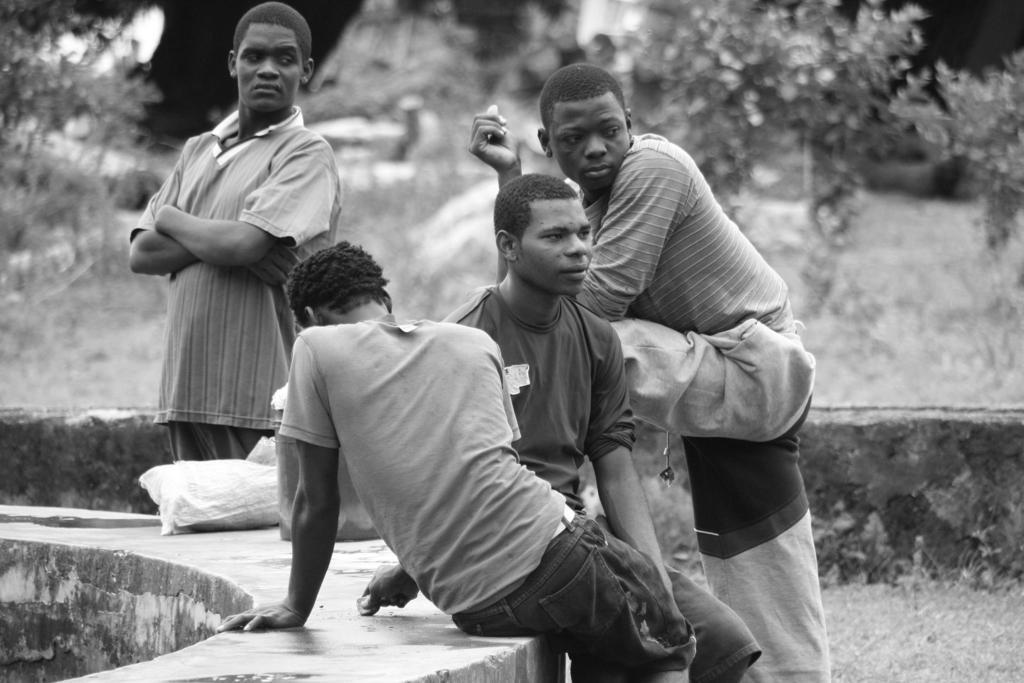How many people are present in the image? There are four people in the image. Can you describe the position of one person in the image? One person is sitting in front. What can be seen in the background of the image? There are trees, a bench, and a wall visible in the background. What is the color scheme of the image? The image is in black and white. Can you see any bubbles floating around the people in the image? There are no bubbles present in the image. What type of quilt is being used by the people in the image? There is no quilt visible in the image. 